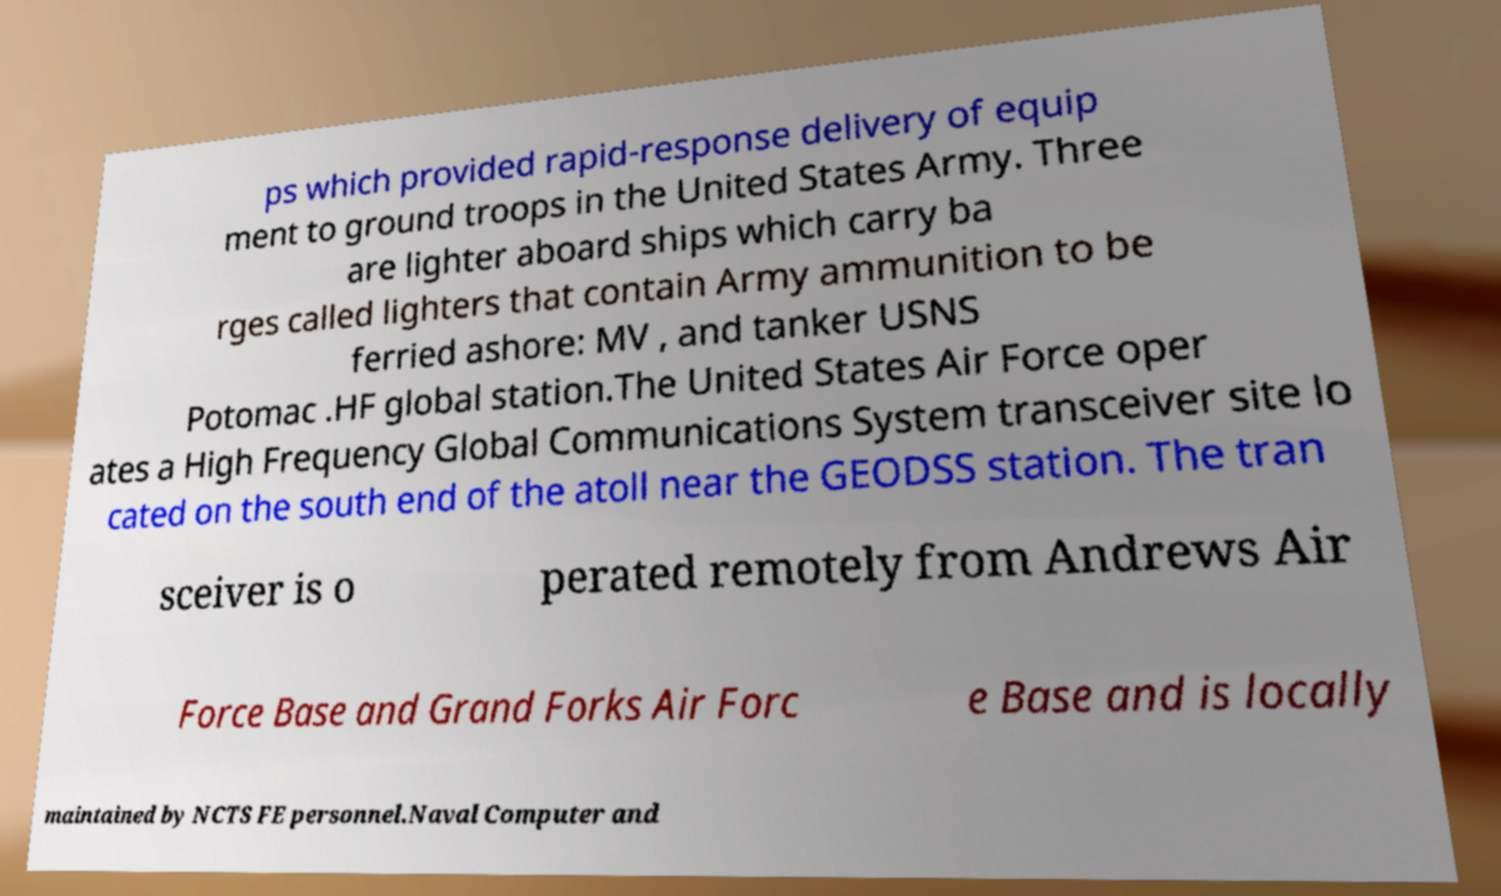Please identify and transcribe the text found in this image. ps which provided rapid-response delivery of equip ment to ground troops in the United States Army. Three are lighter aboard ships which carry ba rges called lighters that contain Army ammunition to be ferried ashore: MV , and tanker USNS Potomac .HF global station.The United States Air Force oper ates a High Frequency Global Communications System transceiver site lo cated on the south end of the atoll near the GEODSS station. The tran sceiver is o perated remotely from Andrews Air Force Base and Grand Forks Air Forc e Base and is locally maintained by NCTS FE personnel.Naval Computer and 